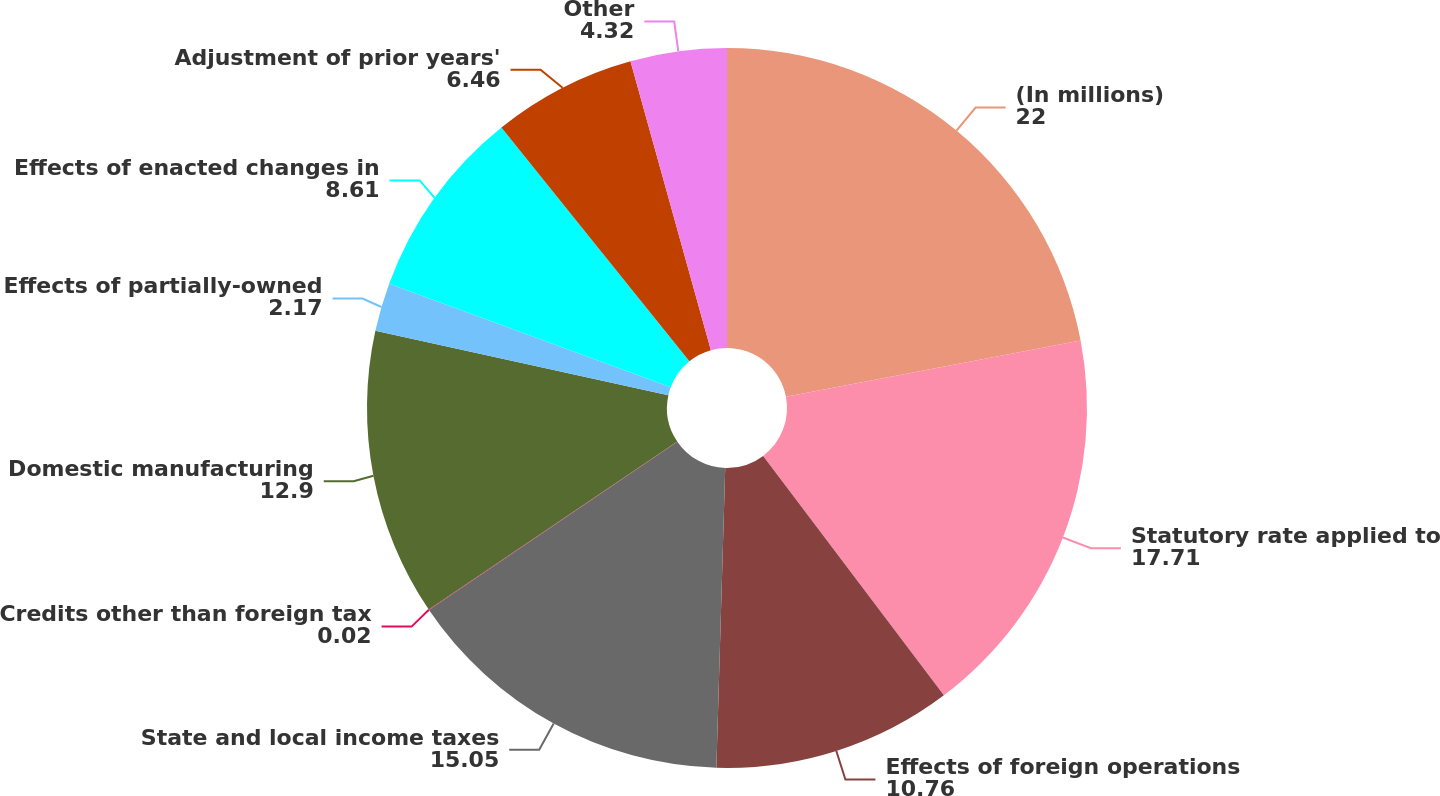<chart> <loc_0><loc_0><loc_500><loc_500><pie_chart><fcel>(In millions)<fcel>Statutory rate applied to<fcel>Effects of foreign operations<fcel>State and local income taxes<fcel>Credits other than foreign tax<fcel>Domestic manufacturing<fcel>Effects of partially-owned<fcel>Effects of enacted changes in<fcel>Adjustment of prior years'<fcel>Other<nl><fcel>22.0%<fcel>17.71%<fcel>10.76%<fcel>15.05%<fcel>0.02%<fcel>12.9%<fcel>2.17%<fcel>8.61%<fcel>6.46%<fcel>4.32%<nl></chart> 